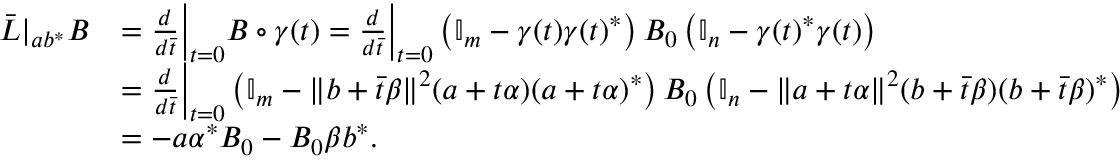<formula> <loc_0><loc_0><loc_500><loc_500>\begin{array} { r l } { \ B a r L | _ { a b ^ { \ast } } B } & { = \frac { d } { d \ B a r t } \Big | _ { t = 0 } B \circ \gamma ( t ) = \frac { d } { d \ B a r t } \Big | _ { t = 0 } \left ( \mathbb { I } _ { m } - \gamma ( t ) \gamma ( t ) ^ { \ast } \right ) B _ { 0 } \left ( \mathbb { I } _ { n } - \gamma ( t ) ^ { \ast } \gamma ( t ) \right ) } \\ & { = \frac { d } { d \ B a r t } \Big | _ { t = 0 } \left ( \mathbb { I } _ { m } - \| b + \ B a r t \beta \| ^ { 2 } ( a + t \alpha ) ( a + t \alpha ) ^ { \ast } \right ) B _ { 0 } \left ( \mathbb { I } _ { n } - \| a + t \alpha \| ^ { 2 } ( b + \ B a r t \beta ) ( b + \ B a r t \beta ) ^ { \ast } \right ) } \\ & { = - a \alpha ^ { \ast } B _ { 0 } - B _ { 0 } \beta b ^ { \ast } . } \end{array}</formula> 